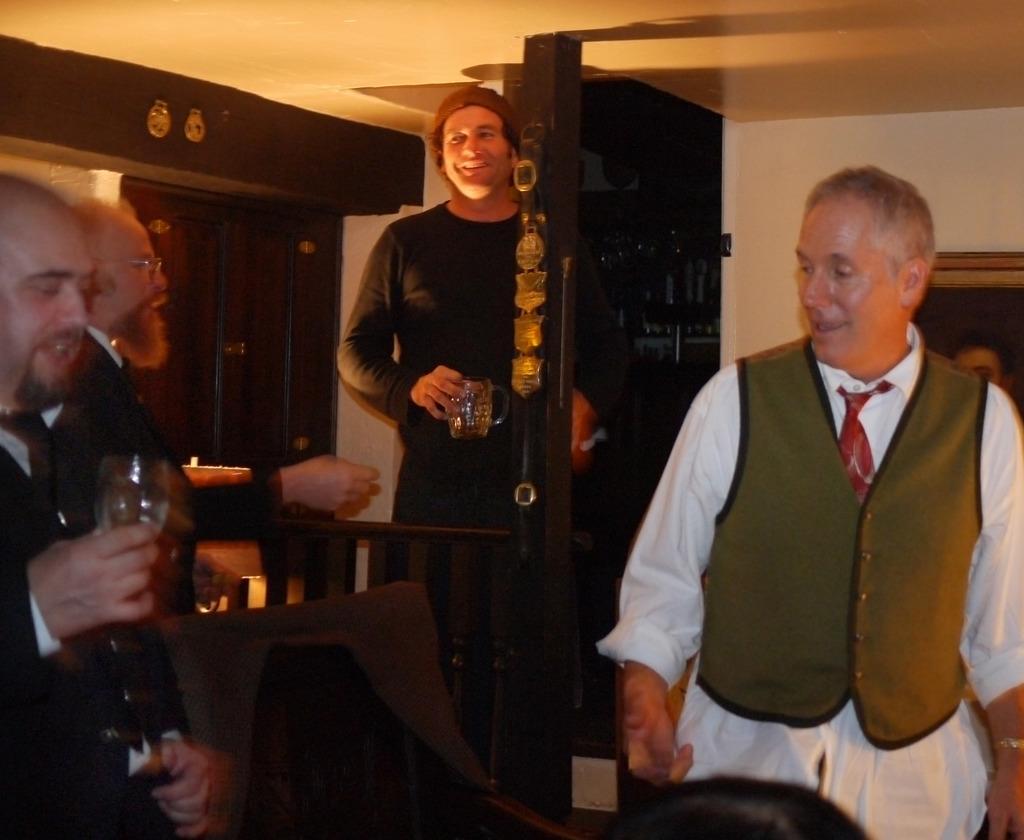Please provide a concise description of this image. It is a picture, there are total four men in the picture first man is talking something the remaining people are holding glasses in their hands , in the background there is a white color wall. 